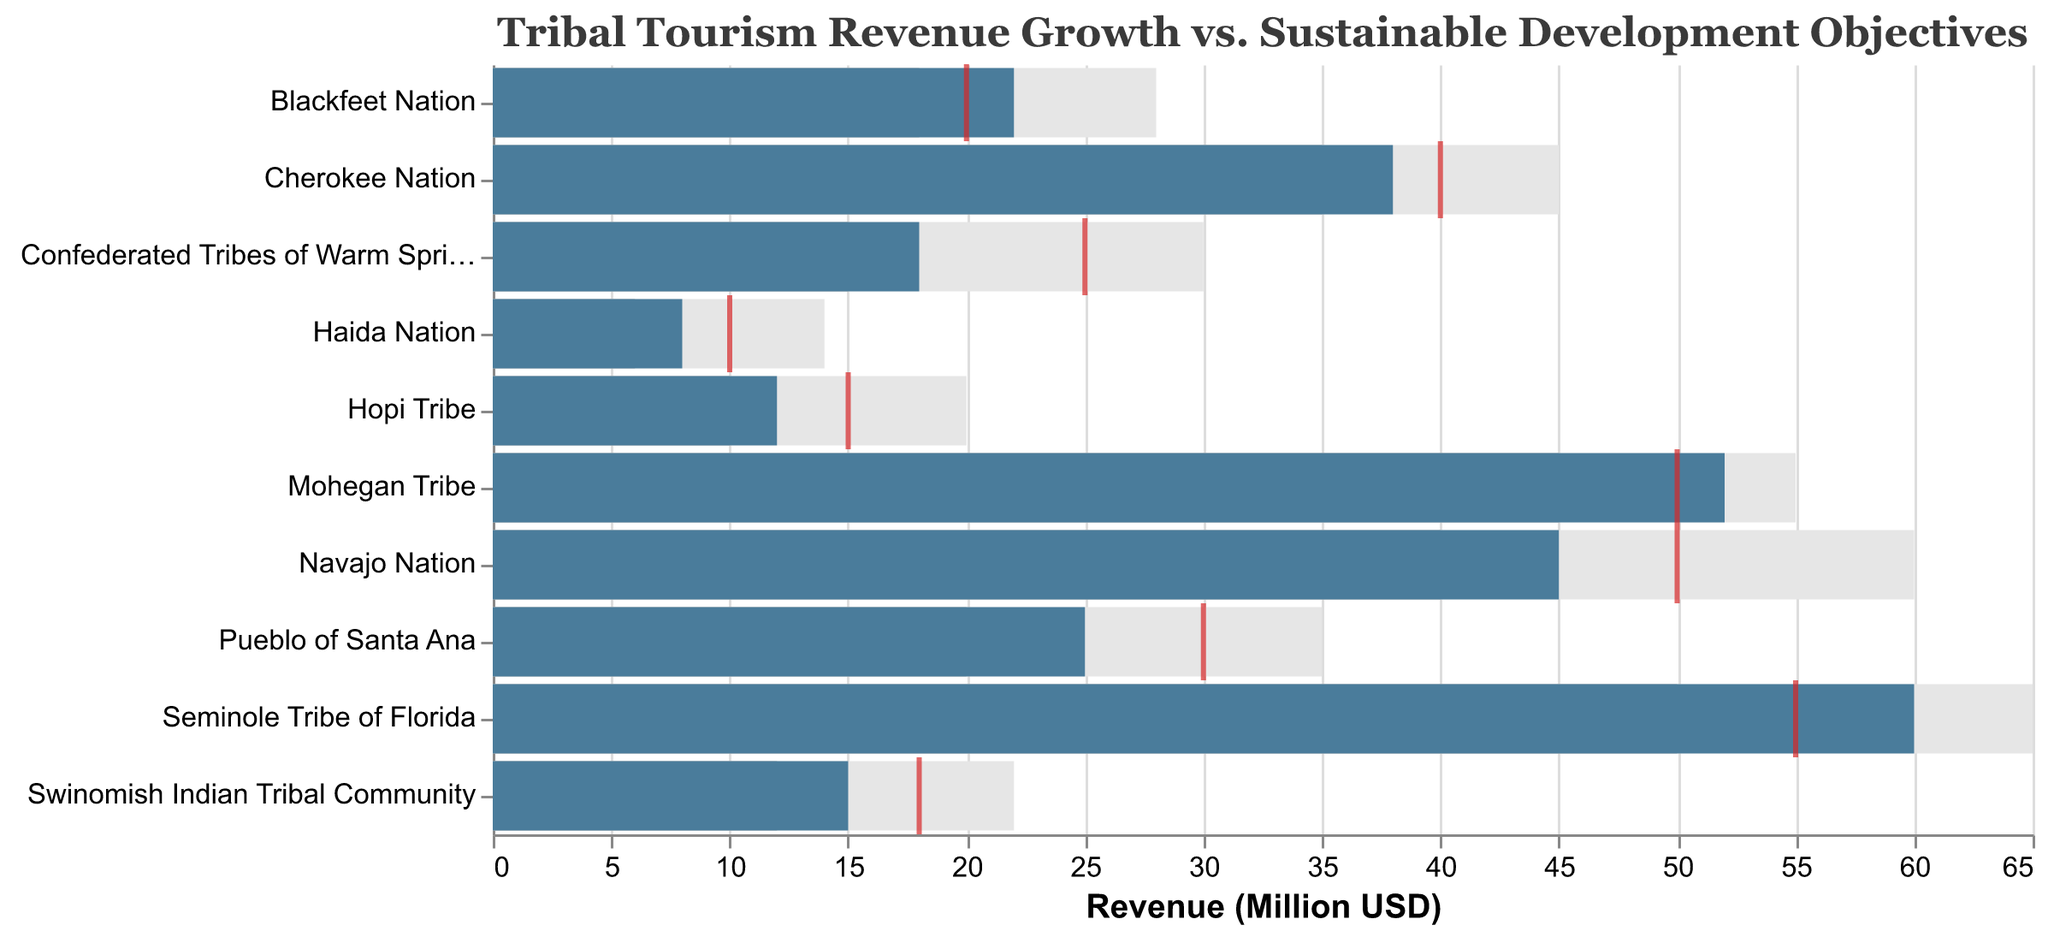What's the title of the chart? The title is displayed at the top of the figure. It reads "Tribal Tourism Revenue Growth vs. Sustainable Development Objectives".
Answer: Tribal Tourism Revenue Growth vs. Sustainable Development Objectives What tribe has the highest revenue? The highest revenue bar is the tallest among all tribes and belongs to the "Seminole Tribe of Florida".
Answer: Seminole Tribe of Florida Which tribe's revenue exceeds its target? Compare the revenue bar and the red target tick for each tribe. The "Blackfeet Nation" has a revenue of 22 million USD, which exceeds its target of 20 million USD.
Answer: Blackfeet Nation What is the average revenue for the "Pueblo of Santa Ana"? Locate the "Pueblo of Santa Ana" row and find the average bar, which is the middle grey segment. It shows an average revenue of 20 million USD.
Answer: 20 million USD Which tribes have a target revenue of 50 million USD? Look for the red target ticks at the 50 million USD position. The "Navajo Nation" and "Mohegan Tribe" both have their targets there.
Answer: Navajo Nation, Mohegan Tribe Calculate the difference between target and actual revenue for the "Cherokee Nation". For "Cherokee Nation", the target is 40 million USD and the revenue is 38 million USD. The difference is 40 - 38 = 2 million USD.
Answer: 2 million USD Which tribe has the smallest maximum potential revenue? The smallest maximum bar is the shortest among the tribes, which belongs to the "Haida Nation" with 14 million USD.
Answer: Haida Nation How many tribes have actual revenue less than their average revenue? Compare the revenue bar to the average bar for all tribes. The tribes where revenue is less than average are the "Pueblo of Santa Ana", "Confederated Tribes of Warm Springs", "Swinomish Indian Tribal Community", and "Hopi Tribe".
Answer: 4 tribes What is the color used for the actual revenue bars? The actual revenue bars are colored in a darker shade, specifically a deep blue color.
Answer: Deep blue What tribe's actual revenue is closest to its maximum potential revenue? Compare the ends of the actual revenue bars to the tops of the maximum bars. "Seminole Tribe of Florida" has a revenue of 60 million USD while its maximum is 65 million USD, making it the closest match.
Answer: Seminole Tribe of Florida 